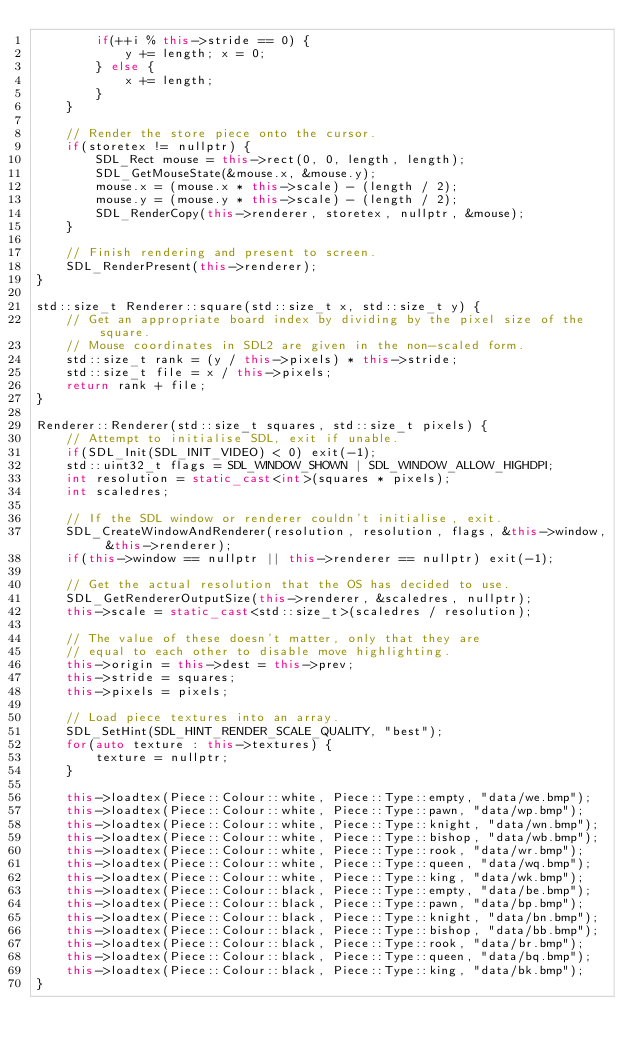<code> <loc_0><loc_0><loc_500><loc_500><_C++_>        if(++i % this->stride == 0) {
            y += length; x = 0;
        } else {
            x += length;
        }
    }

    // Render the store piece onto the cursor.
    if(storetex != nullptr) {
        SDL_Rect mouse = this->rect(0, 0, length, length);
        SDL_GetMouseState(&mouse.x, &mouse.y);
        mouse.x = (mouse.x * this->scale) - (length / 2);
        mouse.y = (mouse.y * this->scale) - (length / 2);
        SDL_RenderCopy(this->renderer, storetex, nullptr, &mouse);
    }

    // Finish rendering and present to screen.
    SDL_RenderPresent(this->renderer);
}

std::size_t Renderer::square(std::size_t x, std::size_t y) {
    // Get an appropriate board index by dividing by the pixel size of the square.
    // Mouse coordinates in SDL2 are given in the non-scaled form.
    std::size_t rank = (y / this->pixels) * this->stride;
    std::size_t file = x / this->pixels;
    return rank + file;
}

Renderer::Renderer(std::size_t squares, std::size_t pixels) {
    // Attempt to initialise SDL, exit if unable.
    if(SDL_Init(SDL_INIT_VIDEO) < 0) exit(-1);
    std::uint32_t flags = SDL_WINDOW_SHOWN | SDL_WINDOW_ALLOW_HIGHDPI;
    int resolution = static_cast<int>(squares * pixels);
    int scaledres;

    // If the SDL window or renderer couldn't initialise, exit.
    SDL_CreateWindowAndRenderer(resolution, resolution, flags, &this->window, &this->renderer);
    if(this->window == nullptr || this->renderer == nullptr) exit(-1);

    // Get the actual resolution that the OS has decided to use.
    SDL_GetRendererOutputSize(this->renderer, &scaledres, nullptr);
    this->scale = static_cast<std::size_t>(scaledres / resolution);

    // The value of these doesn't matter, only that they are
    // equal to each other to disable move highlighting.
    this->origin = this->dest = this->prev;
    this->stride = squares;
    this->pixels = pixels;

    // Load piece textures into an array.
    SDL_SetHint(SDL_HINT_RENDER_SCALE_QUALITY, "best");
    for(auto texture : this->textures) {
        texture = nullptr;
    }

    this->loadtex(Piece::Colour::white, Piece::Type::empty, "data/we.bmp");
    this->loadtex(Piece::Colour::white, Piece::Type::pawn, "data/wp.bmp");
    this->loadtex(Piece::Colour::white, Piece::Type::knight, "data/wn.bmp");
    this->loadtex(Piece::Colour::white, Piece::Type::bishop, "data/wb.bmp");
    this->loadtex(Piece::Colour::white, Piece::Type::rook, "data/wr.bmp");
    this->loadtex(Piece::Colour::white, Piece::Type::queen, "data/wq.bmp");
    this->loadtex(Piece::Colour::white, Piece::Type::king, "data/wk.bmp");
    this->loadtex(Piece::Colour::black, Piece::Type::empty, "data/be.bmp");
    this->loadtex(Piece::Colour::black, Piece::Type::pawn, "data/bp.bmp");
    this->loadtex(Piece::Colour::black, Piece::Type::knight, "data/bn.bmp");
    this->loadtex(Piece::Colour::black, Piece::Type::bishop, "data/bb.bmp");
    this->loadtex(Piece::Colour::black, Piece::Type::rook, "data/br.bmp");
    this->loadtex(Piece::Colour::black, Piece::Type::queen, "data/bq.bmp");
    this->loadtex(Piece::Colour::black, Piece::Type::king, "data/bk.bmp");
}
</code> 